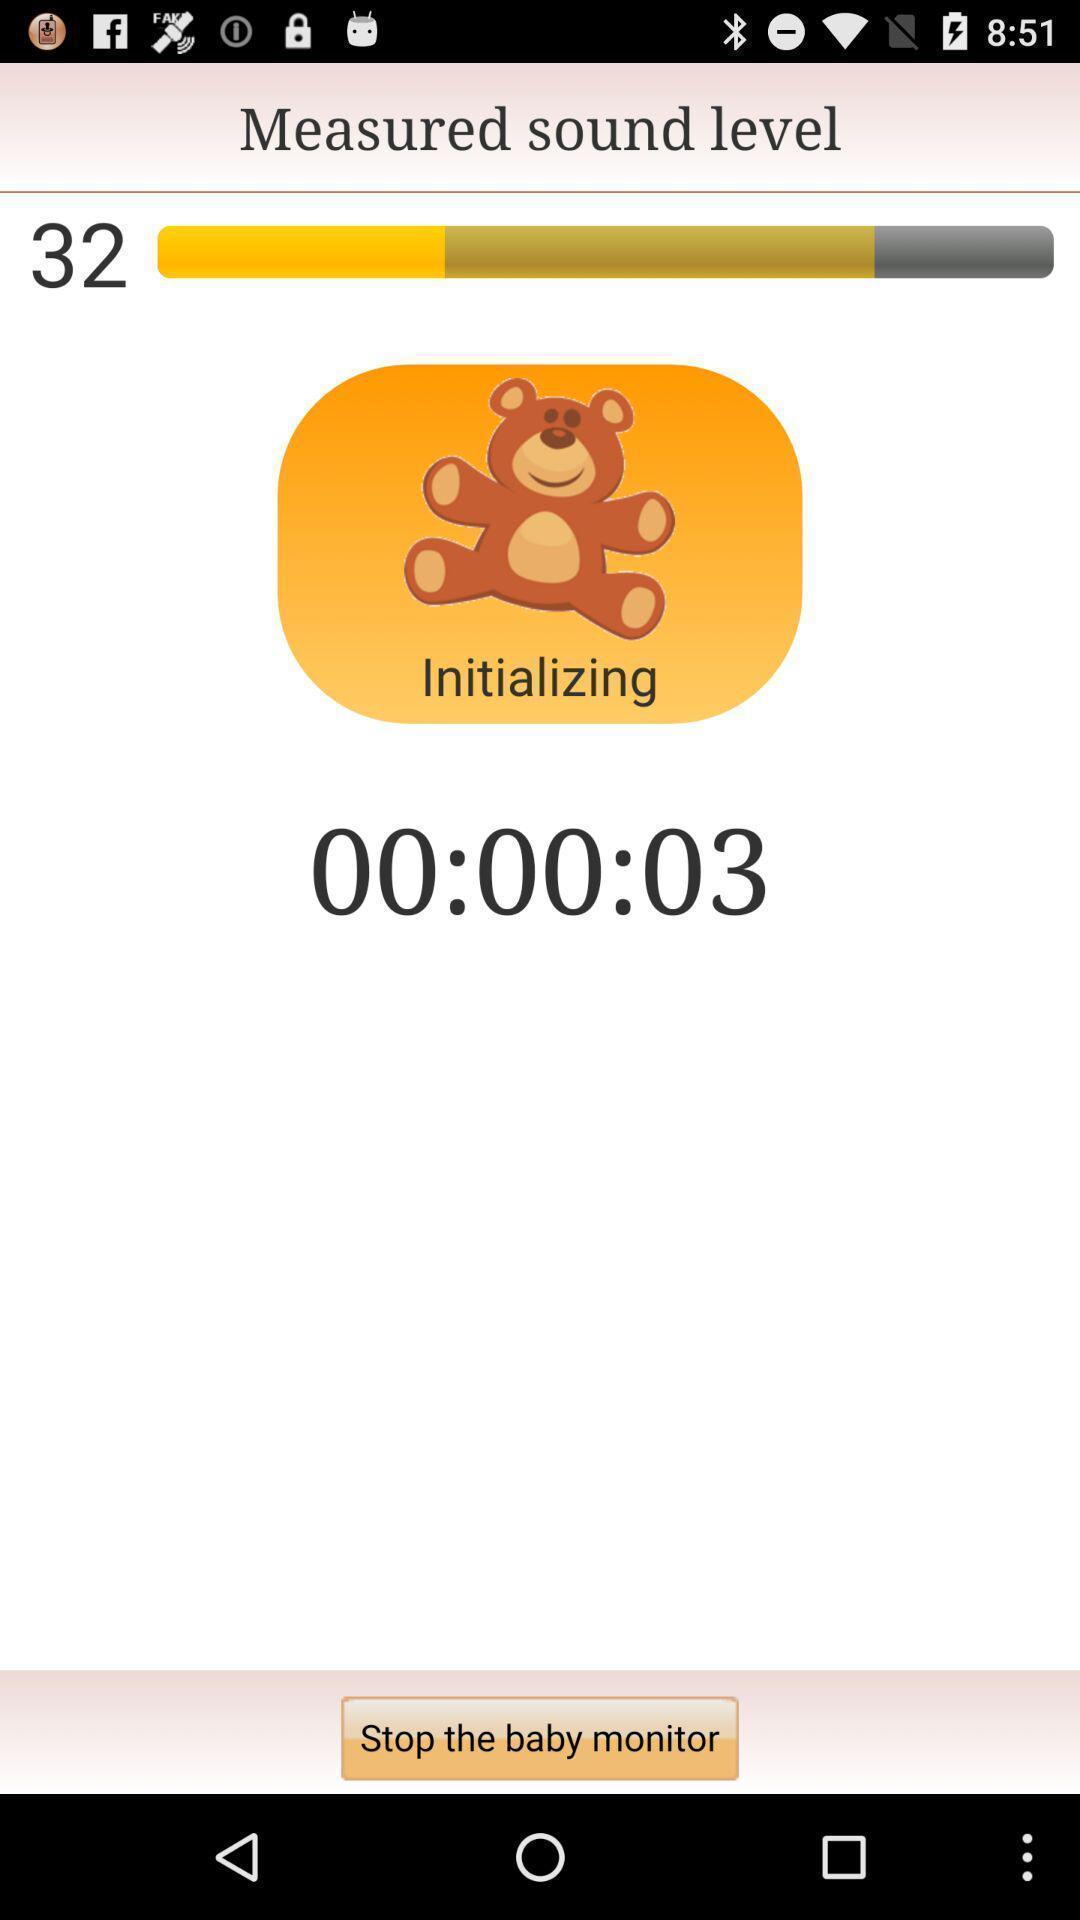Give me a summary of this screen capture. Screen showing sound level option. 